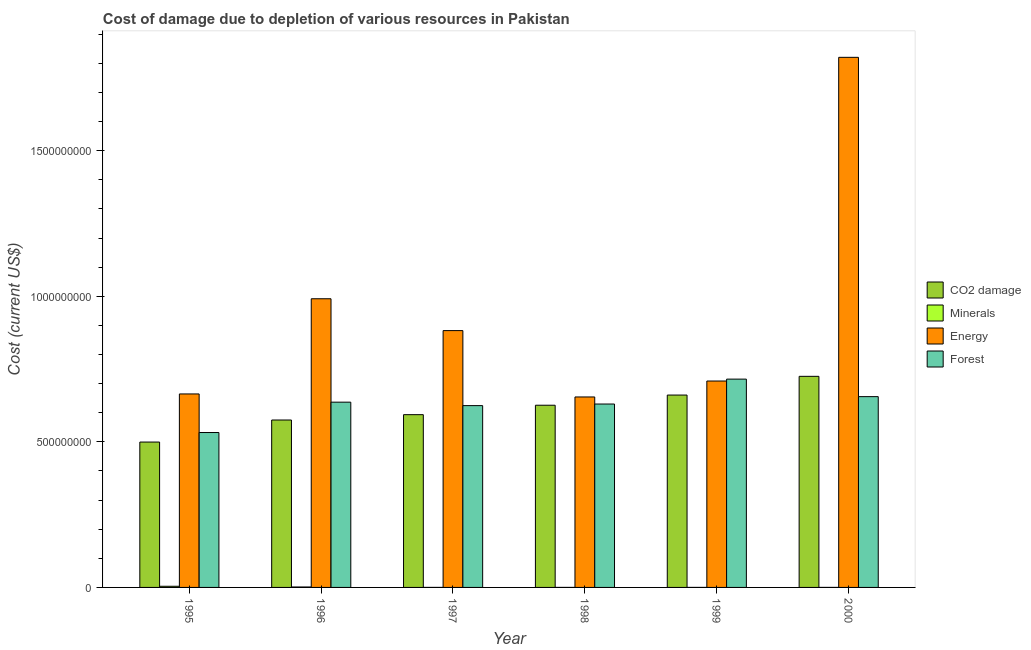Are the number of bars per tick equal to the number of legend labels?
Give a very brief answer. Yes. Are the number of bars on each tick of the X-axis equal?
Your answer should be compact. Yes. How many bars are there on the 1st tick from the left?
Give a very brief answer. 4. How many bars are there on the 1st tick from the right?
Make the answer very short. 4. What is the label of the 2nd group of bars from the left?
Offer a terse response. 1996. In how many cases, is the number of bars for a given year not equal to the number of legend labels?
Provide a short and direct response. 0. What is the cost of damage due to depletion of energy in 2000?
Make the answer very short. 1.82e+09. Across all years, what is the maximum cost of damage due to depletion of coal?
Keep it short and to the point. 7.25e+08. Across all years, what is the minimum cost of damage due to depletion of minerals?
Your answer should be compact. 3.19e+04. In which year was the cost of damage due to depletion of energy maximum?
Offer a very short reply. 2000. In which year was the cost of damage due to depletion of coal minimum?
Your answer should be very brief. 1995. What is the total cost of damage due to depletion of coal in the graph?
Your answer should be very brief. 3.68e+09. What is the difference between the cost of damage due to depletion of minerals in 1999 and that in 2000?
Your answer should be compact. 6647.78. What is the difference between the cost of damage due to depletion of minerals in 1998 and the cost of damage due to depletion of energy in 2000?
Offer a very short reply. -2.28e+04. What is the average cost of damage due to depletion of forests per year?
Offer a very short reply. 6.32e+08. In the year 1996, what is the difference between the cost of damage due to depletion of energy and cost of damage due to depletion of forests?
Offer a very short reply. 0. What is the ratio of the cost of damage due to depletion of energy in 1996 to that in 2000?
Ensure brevity in your answer.  0.54. What is the difference between the highest and the second highest cost of damage due to depletion of coal?
Keep it short and to the point. 6.43e+07. What is the difference between the highest and the lowest cost of damage due to depletion of energy?
Your answer should be very brief. 1.17e+09. Is the sum of the cost of damage due to depletion of forests in 1995 and 1998 greater than the maximum cost of damage due to depletion of coal across all years?
Offer a very short reply. Yes. Is it the case that in every year, the sum of the cost of damage due to depletion of minerals and cost of damage due to depletion of forests is greater than the sum of cost of damage due to depletion of coal and cost of damage due to depletion of energy?
Your response must be concise. No. What does the 1st bar from the left in 1996 represents?
Your answer should be compact. CO2 damage. What does the 2nd bar from the right in 1996 represents?
Your answer should be very brief. Energy. Are all the bars in the graph horizontal?
Your answer should be very brief. No. How many years are there in the graph?
Give a very brief answer. 6. What is the difference between two consecutive major ticks on the Y-axis?
Provide a short and direct response. 5.00e+08. Does the graph contain any zero values?
Offer a very short reply. No. How many legend labels are there?
Keep it short and to the point. 4. What is the title of the graph?
Provide a succinct answer. Cost of damage due to depletion of various resources in Pakistan . What is the label or title of the Y-axis?
Ensure brevity in your answer.  Cost (current US$). What is the Cost (current US$) in CO2 damage in 1995?
Your response must be concise. 4.99e+08. What is the Cost (current US$) of Minerals in 1995?
Make the answer very short. 3.95e+06. What is the Cost (current US$) in Energy in 1995?
Ensure brevity in your answer.  6.64e+08. What is the Cost (current US$) of Forest in 1995?
Your answer should be compact. 5.32e+08. What is the Cost (current US$) in CO2 damage in 1996?
Your response must be concise. 5.75e+08. What is the Cost (current US$) in Minerals in 1996?
Keep it short and to the point. 1.50e+06. What is the Cost (current US$) in Energy in 1996?
Make the answer very short. 9.91e+08. What is the Cost (current US$) of Forest in 1996?
Provide a succinct answer. 6.36e+08. What is the Cost (current US$) of CO2 damage in 1997?
Keep it short and to the point. 5.93e+08. What is the Cost (current US$) of Minerals in 1997?
Make the answer very short. 3.32e+04. What is the Cost (current US$) of Energy in 1997?
Provide a short and direct response. 8.82e+08. What is the Cost (current US$) of Forest in 1997?
Make the answer very short. 6.24e+08. What is the Cost (current US$) of CO2 damage in 1998?
Provide a short and direct response. 6.26e+08. What is the Cost (current US$) of Minerals in 1998?
Make the answer very short. 3.19e+04. What is the Cost (current US$) of Energy in 1998?
Give a very brief answer. 6.54e+08. What is the Cost (current US$) in Forest in 1998?
Your answer should be compact. 6.30e+08. What is the Cost (current US$) in CO2 damage in 1999?
Offer a terse response. 6.61e+08. What is the Cost (current US$) in Minerals in 1999?
Offer a very short reply. 6.14e+04. What is the Cost (current US$) of Energy in 1999?
Your response must be concise. 7.09e+08. What is the Cost (current US$) in Forest in 1999?
Offer a very short reply. 7.15e+08. What is the Cost (current US$) of CO2 damage in 2000?
Your answer should be compact. 7.25e+08. What is the Cost (current US$) of Minerals in 2000?
Offer a terse response. 5.47e+04. What is the Cost (current US$) of Energy in 2000?
Your answer should be compact. 1.82e+09. What is the Cost (current US$) of Forest in 2000?
Offer a very short reply. 6.55e+08. Across all years, what is the maximum Cost (current US$) of CO2 damage?
Keep it short and to the point. 7.25e+08. Across all years, what is the maximum Cost (current US$) of Minerals?
Your answer should be very brief. 3.95e+06. Across all years, what is the maximum Cost (current US$) of Energy?
Your answer should be compact. 1.82e+09. Across all years, what is the maximum Cost (current US$) of Forest?
Provide a succinct answer. 7.15e+08. Across all years, what is the minimum Cost (current US$) of CO2 damage?
Keep it short and to the point. 4.99e+08. Across all years, what is the minimum Cost (current US$) of Minerals?
Provide a succinct answer. 3.19e+04. Across all years, what is the minimum Cost (current US$) in Energy?
Your answer should be compact. 6.54e+08. Across all years, what is the minimum Cost (current US$) of Forest?
Your answer should be very brief. 5.32e+08. What is the total Cost (current US$) of CO2 damage in the graph?
Ensure brevity in your answer.  3.68e+09. What is the total Cost (current US$) of Minerals in the graph?
Provide a succinct answer. 5.63e+06. What is the total Cost (current US$) of Energy in the graph?
Offer a very short reply. 5.72e+09. What is the total Cost (current US$) of Forest in the graph?
Provide a short and direct response. 3.79e+09. What is the difference between the Cost (current US$) of CO2 damage in 1995 and that in 1996?
Offer a very short reply. -7.57e+07. What is the difference between the Cost (current US$) in Minerals in 1995 and that in 1996?
Ensure brevity in your answer.  2.45e+06. What is the difference between the Cost (current US$) of Energy in 1995 and that in 1996?
Your answer should be very brief. -3.27e+08. What is the difference between the Cost (current US$) in Forest in 1995 and that in 1996?
Give a very brief answer. -1.04e+08. What is the difference between the Cost (current US$) in CO2 damage in 1995 and that in 1997?
Ensure brevity in your answer.  -9.41e+07. What is the difference between the Cost (current US$) of Minerals in 1995 and that in 1997?
Make the answer very short. 3.92e+06. What is the difference between the Cost (current US$) of Energy in 1995 and that in 1997?
Your answer should be compact. -2.18e+08. What is the difference between the Cost (current US$) of Forest in 1995 and that in 1997?
Make the answer very short. -9.24e+07. What is the difference between the Cost (current US$) in CO2 damage in 1995 and that in 1998?
Your response must be concise. -1.27e+08. What is the difference between the Cost (current US$) in Minerals in 1995 and that in 1998?
Your answer should be very brief. 3.92e+06. What is the difference between the Cost (current US$) of Energy in 1995 and that in 1998?
Provide a succinct answer. 1.03e+07. What is the difference between the Cost (current US$) of Forest in 1995 and that in 1998?
Your response must be concise. -9.79e+07. What is the difference between the Cost (current US$) in CO2 damage in 1995 and that in 1999?
Your answer should be compact. -1.61e+08. What is the difference between the Cost (current US$) in Minerals in 1995 and that in 1999?
Give a very brief answer. 3.89e+06. What is the difference between the Cost (current US$) in Energy in 1995 and that in 1999?
Your response must be concise. -4.44e+07. What is the difference between the Cost (current US$) of Forest in 1995 and that in 1999?
Ensure brevity in your answer.  -1.83e+08. What is the difference between the Cost (current US$) in CO2 damage in 1995 and that in 2000?
Your answer should be very brief. -2.26e+08. What is the difference between the Cost (current US$) in Minerals in 1995 and that in 2000?
Make the answer very short. 3.90e+06. What is the difference between the Cost (current US$) in Energy in 1995 and that in 2000?
Keep it short and to the point. -1.16e+09. What is the difference between the Cost (current US$) in Forest in 1995 and that in 2000?
Your response must be concise. -1.23e+08. What is the difference between the Cost (current US$) in CO2 damage in 1996 and that in 1997?
Provide a short and direct response. -1.84e+07. What is the difference between the Cost (current US$) of Minerals in 1996 and that in 1997?
Keep it short and to the point. 1.47e+06. What is the difference between the Cost (current US$) of Energy in 1996 and that in 1997?
Your answer should be compact. 1.09e+08. What is the difference between the Cost (current US$) in Forest in 1996 and that in 1997?
Give a very brief answer. 1.18e+07. What is the difference between the Cost (current US$) of CO2 damage in 1996 and that in 1998?
Your response must be concise. -5.08e+07. What is the difference between the Cost (current US$) in Minerals in 1996 and that in 1998?
Offer a terse response. 1.47e+06. What is the difference between the Cost (current US$) of Energy in 1996 and that in 1998?
Offer a terse response. 3.37e+08. What is the difference between the Cost (current US$) of Forest in 1996 and that in 1998?
Provide a succinct answer. 6.40e+06. What is the difference between the Cost (current US$) in CO2 damage in 1996 and that in 1999?
Provide a succinct answer. -8.57e+07. What is the difference between the Cost (current US$) in Minerals in 1996 and that in 1999?
Make the answer very short. 1.44e+06. What is the difference between the Cost (current US$) in Energy in 1996 and that in 1999?
Provide a succinct answer. 2.83e+08. What is the difference between the Cost (current US$) in Forest in 1996 and that in 1999?
Keep it short and to the point. -7.91e+07. What is the difference between the Cost (current US$) in CO2 damage in 1996 and that in 2000?
Your answer should be very brief. -1.50e+08. What is the difference between the Cost (current US$) in Minerals in 1996 and that in 2000?
Your response must be concise. 1.45e+06. What is the difference between the Cost (current US$) of Energy in 1996 and that in 2000?
Your response must be concise. -8.29e+08. What is the difference between the Cost (current US$) in Forest in 1996 and that in 2000?
Make the answer very short. -1.90e+07. What is the difference between the Cost (current US$) of CO2 damage in 1997 and that in 1998?
Provide a short and direct response. -3.24e+07. What is the difference between the Cost (current US$) of Minerals in 1997 and that in 1998?
Provide a succinct answer. 1244.87. What is the difference between the Cost (current US$) of Energy in 1997 and that in 1998?
Make the answer very short. 2.28e+08. What is the difference between the Cost (current US$) of Forest in 1997 and that in 1998?
Keep it short and to the point. -5.44e+06. What is the difference between the Cost (current US$) in CO2 damage in 1997 and that in 1999?
Ensure brevity in your answer.  -6.74e+07. What is the difference between the Cost (current US$) in Minerals in 1997 and that in 1999?
Ensure brevity in your answer.  -2.82e+04. What is the difference between the Cost (current US$) of Energy in 1997 and that in 1999?
Keep it short and to the point. 1.73e+08. What is the difference between the Cost (current US$) of Forest in 1997 and that in 1999?
Provide a short and direct response. -9.10e+07. What is the difference between the Cost (current US$) in CO2 damage in 1997 and that in 2000?
Make the answer very short. -1.32e+08. What is the difference between the Cost (current US$) in Minerals in 1997 and that in 2000?
Your answer should be compact. -2.15e+04. What is the difference between the Cost (current US$) of Energy in 1997 and that in 2000?
Ensure brevity in your answer.  -9.39e+08. What is the difference between the Cost (current US$) of Forest in 1997 and that in 2000?
Keep it short and to the point. -3.09e+07. What is the difference between the Cost (current US$) in CO2 damage in 1998 and that in 1999?
Your answer should be compact. -3.50e+07. What is the difference between the Cost (current US$) of Minerals in 1998 and that in 1999?
Your answer should be compact. -2.94e+04. What is the difference between the Cost (current US$) in Energy in 1998 and that in 1999?
Offer a terse response. -5.47e+07. What is the difference between the Cost (current US$) of Forest in 1998 and that in 1999?
Your answer should be very brief. -8.55e+07. What is the difference between the Cost (current US$) in CO2 damage in 1998 and that in 2000?
Offer a very short reply. -9.92e+07. What is the difference between the Cost (current US$) in Minerals in 1998 and that in 2000?
Your response must be concise. -2.28e+04. What is the difference between the Cost (current US$) of Energy in 1998 and that in 2000?
Keep it short and to the point. -1.17e+09. What is the difference between the Cost (current US$) of Forest in 1998 and that in 2000?
Provide a succinct answer. -2.54e+07. What is the difference between the Cost (current US$) in CO2 damage in 1999 and that in 2000?
Keep it short and to the point. -6.43e+07. What is the difference between the Cost (current US$) in Minerals in 1999 and that in 2000?
Offer a terse response. 6647.78. What is the difference between the Cost (current US$) in Energy in 1999 and that in 2000?
Give a very brief answer. -1.11e+09. What is the difference between the Cost (current US$) of Forest in 1999 and that in 2000?
Make the answer very short. 6.01e+07. What is the difference between the Cost (current US$) in CO2 damage in 1995 and the Cost (current US$) in Minerals in 1996?
Keep it short and to the point. 4.98e+08. What is the difference between the Cost (current US$) of CO2 damage in 1995 and the Cost (current US$) of Energy in 1996?
Make the answer very short. -4.92e+08. What is the difference between the Cost (current US$) in CO2 damage in 1995 and the Cost (current US$) in Forest in 1996?
Provide a short and direct response. -1.37e+08. What is the difference between the Cost (current US$) in Minerals in 1995 and the Cost (current US$) in Energy in 1996?
Ensure brevity in your answer.  -9.87e+08. What is the difference between the Cost (current US$) in Minerals in 1995 and the Cost (current US$) in Forest in 1996?
Offer a very short reply. -6.32e+08. What is the difference between the Cost (current US$) in Energy in 1995 and the Cost (current US$) in Forest in 1996?
Keep it short and to the point. 2.82e+07. What is the difference between the Cost (current US$) in CO2 damage in 1995 and the Cost (current US$) in Minerals in 1997?
Provide a succinct answer. 4.99e+08. What is the difference between the Cost (current US$) of CO2 damage in 1995 and the Cost (current US$) of Energy in 1997?
Offer a very short reply. -3.83e+08. What is the difference between the Cost (current US$) in CO2 damage in 1995 and the Cost (current US$) in Forest in 1997?
Ensure brevity in your answer.  -1.25e+08. What is the difference between the Cost (current US$) in Minerals in 1995 and the Cost (current US$) in Energy in 1997?
Provide a succinct answer. -8.78e+08. What is the difference between the Cost (current US$) in Minerals in 1995 and the Cost (current US$) in Forest in 1997?
Your answer should be compact. -6.20e+08. What is the difference between the Cost (current US$) in Energy in 1995 and the Cost (current US$) in Forest in 1997?
Give a very brief answer. 4.00e+07. What is the difference between the Cost (current US$) in CO2 damage in 1995 and the Cost (current US$) in Minerals in 1998?
Provide a succinct answer. 4.99e+08. What is the difference between the Cost (current US$) in CO2 damage in 1995 and the Cost (current US$) in Energy in 1998?
Your answer should be very brief. -1.55e+08. What is the difference between the Cost (current US$) in CO2 damage in 1995 and the Cost (current US$) in Forest in 1998?
Make the answer very short. -1.31e+08. What is the difference between the Cost (current US$) in Minerals in 1995 and the Cost (current US$) in Energy in 1998?
Provide a succinct answer. -6.50e+08. What is the difference between the Cost (current US$) of Minerals in 1995 and the Cost (current US$) of Forest in 1998?
Offer a terse response. -6.26e+08. What is the difference between the Cost (current US$) of Energy in 1995 and the Cost (current US$) of Forest in 1998?
Make the answer very short. 3.46e+07. What is the difference between the Cost (current US$) of CO2 damage in 1995 and the Cost (current US$) of Minerals in 1999?
Provide a short and direct response. 4.99e+08. What is the difference between the Cost (current US$) in CO2 damage in 1995 and the Cost (current US$) in Energy in 1999?
Give a very brief answer. -2.10e+08. What is the difference between the Cost (current US$) in CO2 damage in 1995 and the Cost (current US$) in Forest in 1999?
Offer a terse response. -2.16e+08. What is the difference between the Cost (current US$) in Minerals in 1995 and the Cost (current US$) in Energy in 1999?
Provide a succinct answer. -7.05e+08. What is the difference between the Cost (current US$) in Minerals in 1995 and the Cost (current US$) in Forest in 1999?
Provide a succinct answer. -7.11e+08. What is the difference between the Cost (current US$) of Energy in 1995 and the Cost (current US$) of Forest in 1999?
Your response must be concise. -5.09e+07. What is the difference between the Cost (current US$) in CO2 damage in 1995 and the Cost (current US$) in Minerals in 2000?
Ensure brevity in your answer.  4.99e+08. What is the difference between the Cost (current US$) of CO2 damage in 1995 and the Cost (current US$) of Energy in 2000?
Offer a terse response. -1.32e+09. What is the difference between the Cost (current US$) in CO2 damage in 1995 and the Cost (current US$) in Forest in 2000?
Offer a terse response. -1.56e+08. What is the difference between the Cost (current US$) of Minerals in 1995 and the Cost (current US$) of Energy in 2000?
Your response must be concise. -1.82e+09. What is the difference between the Cost (current US$) of Minerals in 1995 and the Cost (current US$) of Forest in 2000?
Provide a short and direct response. -6.51e+08. What is the difference between the Cost (current US$) in Energy in 1995 and the Cost (current US$) in Forest in 2000?
Offer a very short reply. 9.19e+06. What is the difference between the Cost (current US$) in CO2 damage in 1996 and the Cost (current US$) in Minerals in 1997?
Your answer should be very brief. 5.75e+08. What is the difference between the Cost (current US$) in CO2 damage in 1996 and the Cost (current US$) in Energy in 1997?
Give a very brief answer. -3.07e+08. What is the difference between the Cost (current US$) of CO2 damage in 1996 and the Cost (current US$) of Forest in 1997?
Provide a short and direct response. -4.94e+07. What is the difference between the Cost (current US$) in Minerals in 1996 and the Cost (current US$) in Energy in 1997?
Ensure brevity in your answer.  -8.81e+08. What is the difference between the Cost (current US$) of Minerals in 1996 and the Cost (current US$) of Forest in 1997?
Offer a very short reply. -6.23e+08. What is the difference between the Cost (current US$) of Energy in 1996 and the Cost (current US$) of Forest in 1997?
Your answer should be compact. 3.67e+08. What is the difference between the Cost (current US$) of CO2 damage in 1996 and the Cost (current US$) of Minerals in 1998?
Ensure brevity in your answer.  5.75e+08. What is the difference between the Cost (current US$) of CO2 damage in 1996 and the Cost (current US$) of Energy in 1998?
Offer a very short reply. -7.91e+07. What is the difference between the Cost (current US$) of CO2 damage in 1996 and the Cost (current US$) of Forest in 1998?
Offer a very short reply. -5.49e+07. What is the difference between the Cost (current US$) in Minerals in 1996 and the Cost (current US$) in Energy in 1998?
Give a very brief answer. -6.53e+08. What is the difference between the Cost (current US$) in Minerals in 1996 and the Cost (current US$) in Forest in 1998?
Keep it short and to the point. -6.28e+08. What is the difference between the Cost (current US$) of Energy in 1996 and the Cost (current US$) of Forest in 1998?
Provide a short and direct response. 3.62e+08. What is the difference between the Cost (current US$) of CO2 damage in 1996 and the Cost (current US$) of Minerals in 1999?
Make the answer very short. 5.75e+08. What is the difference between the Cost (current US$) in CO2 damage in 1996 and the Cost (current US$) in Energy in 1999?
Provide a succinct answer. -1.34e+08. What is the difference between the Cost (current US$) of CO2 damage in 1996 and the Cost (current US$) of Forest in 1999?
Your answer should be compact. -1.40e+08. What is the difference between the Cost (current US$) of Minerals in 1996 and the Cost (current US$) of Energy in 1999?
Give a very brief answer. -7.07e+08. What is the difference between the Cost (current US$) in Minerals in 1996 and the Cost (current US$) in Forest in 1999?
Ensure brevity in your answer.  -7.14e+08. What is the difference between the Cost (current US$) in Energy in 1996 and the Cost (current US$) in Forest in 1999?
Your response must be concise. 2.76e+08. What is the difference between the Cost (current US$) in CO2 damage in 1996 and the Cost (current US$) in Minerals in 2000?
Your answer should be compact. 5.75e+08. What is the difference between the Cost (current US$) of CO2 damage in 1996 and the Cost (current US$) of Energy in 2000?
Your answer should be very brief. -1.25e+09. What is the difference between the Cost (current US$) of CO2 damage in 1996 and the Cost (current US$) of Forest in 2000?
Give a very brief answer. -8.03e+07. What is the difference between the Cost (current US$) of Minerals in 1996 and the Cost (current US$) of Energy in 2000?
Make the answer very short. -1.82e+09. What is the difference between the Cost (current US$) in Minerals in 1996 and the Cost (current US$) in Forest in 2000?
Provide a succinct answer. -6.54e+08. What is the difference between the Cost (current US$) in Energy in 1996 and the Cost (current US$) in Forest in 2000?
Provide a short and direct response. 3.36e+08. What is the difference between the Cost (current US$) in CO2 damage in 1997 and the Cost (current US$) in Minerals in 1998?
Your response must be concise. 5.93e+08. What is the difference between the Cost (current US$) in CO2 damage in 1997 and the Cost (current US$) in Energy in 1998?
Your response must be concise. -6.08e+07. What is the difference between the Cost (current US$) of CO2 damage in 1997 and the Cost (current US$) of Forest in 1998?
Keep it short and to the point. -3.65e+07. What is the difference between the Cost (current US$) of Minerals in 1997 and the Cost (current US$) of Energy in 1998?
Your response must be concise. -6.54e+08. What is the difference between the Cost (current US$) of Minerals in 1997 and the Cost (current US$) of Forest in 1998?
Provide a succinct answer. -6.30e+08. What is the difference between the Cost (current US$) of Energy in 1997 and the Cost (current US$) of Forest in 1998?
Offer a terse response. 2.52e+08. What is the difference between the Cost (current US$) of CO2 damage in 1997 and the Cost (current US$) of Minerals in 1999?
Provide a short and direct response. 5.93e+08. What is the difference between the Cost (current US$) in CO2 damage in 1997 and the Cost (current US$) in Energy in 1999?
Keep it short and to the point. -1.16e+08. What is the difference between the Cost (current US$) in CO2 damage in 1997 and the Cost (current US$) in Forest in 1999?
Your answer should be very brief. -1.22e+08. What is the difference between the Cost (current US$) of Minerals in 1997 and the Cost (current US$) of Energy in 1999?
Offer a very short reply. -7.09e+08. What is the difference between the Cost (current US$) of Minerals in 1997 and the Cost (current US$) of Forest in 1999?
Make the answer very short. -7.15e+08. What is the difference between the Cost (current US$) of Energy in 1997 and the Cost (current US$) of Forest in 1999?
Give a very brief answer. 1.67e+08. What is the difference between the Cost (current US$) in CO2 damage in 1997 and the Cost (current US$) in Minerals in 2000?
Give a very brief answer. 5.93e+08. What is the difference between the Cost (current US$) of CO2 damage in 1997 and the Cost (current US$) of Energy in 2000?
Provide a succinct answer. -1.23e+09. What is the difference between the Cost (current US$) of CO2 damage in 1997 and the Cost (current US$) of Forest in 2000?
Ensure brevity in your answer.  -6.19e+07. What is the difference between the Cost (current US$) of Minerals in 1997 and the Cost (current US$) of Energy in 2000?
Keep it short and to the point. -1.82e+09. What is the difference between the Cost (current US$) in Minerals in 1997 and the Cost (current US$) in Forest in 2000?
Give a very brief answer. -6.55e+08. What is the difference between the Cost (current US$) in Energy in 1997 and the Cost (current US$) in Forest in 2000?
Offer a very short reply. 2.27e+08. What is the difference between the Cost (current US$) in CO2 damage in 1998 and the Cost (current US$) in Minerals in 1999?
Make the answer very short. 6.26e+08. What is the difference between the Cost (current US$) of CO2 damage in 1998 and the Cost (current US$) of Energy in 1999?
Your answer should be very brief. -8.31e+07. What is the difference between the Cost (current US$) in CO2 damage in 1998 and the Cost (current US$) in Forest in 1999?
Offer a very short reply. -8.96e+07. What is the difference between the Cost (current US$) of Minerals in 1998 and the Cost (current US$) of Energy in 1999?
Provide a succinct answer. -7.09e+08. What is the difference between the Cost (current US$) in Minerals in 1998 and the Cost (current US$) in Forest in 1999?
Your answer should be very brief. -7.15e+08. What is the difference between the Cost (current US$) in Energy in 1998 and the Cost (current US$) in Forest in 1999?
Provide a succinct answer. -6.13e+07. What is the difference between the Cost (current US$) in CO2 damage in 1998 and the Cost (current US$) in Minerals in 2000?
Your answer should be very brief. 6.26e+08. What is the difference between the Cost (current US$) in CO2 damage in 1998 and the Cost (current US$) in Energy in 2000?
Offer a very short reply. -1.19e+09. What is the difference between the Cost (current US$) of CO2 damage in 1998 and the Cost (current US$) of Forest in 2000?
Ensure brevity in your answer.  -2.95e+07. What is the difference between the Cost (current US$) of Minerals in 1998 and the Cost (current US$) of Energy in 2000?
Keep it short and to the point. -1.82e+09. What is the difference between the Cost (current US$) in Minerals in 1998 and the Cost (current US$) in Forest in 2000?
Provide a short and direct response. -6.55e+08. What is the difference between the Cost (current US$) in Energy in 1998 and the Cost (current US$) in Forest in 2000?
Make the answer very short. -1.16e+06. What is the difference between the Cost (current US$) in CO2 damage in 1999 and the Cost (current US$) in Minerals in 2000?
Keep it short and to the point. 6.61e+08. What is the difference between the Cost (current US$) of CO2 damage in 1999 and the Cost (current US$) of Energy in 2000?
Ensure brevity in your answer.  -1.16e+09. What is the difference between the Cost (current US$) of CO2 damage in 1999 and the Cost (current US$) of Forest in 2000?
Keep it short and to the point. 5.42e+06. What is the difference between the Cost (current US$) of Minerals in 1999 and the Cost (current US$) of Energy in 2000?
Keep it short and to the point. -1.82e+09. What is the difference between the Cost (current US$) in Minerals in 1999 and the Cost (current US$) in Forest in 2000?
Provide a short and direct response. -6.55e+08. What is the difference between the Cost (current US$) of Energy in 1999 and the Cost (current US$) of Forest in 2000?
Keep it short and to the point. 5.36e+07. What is the average Cost (current US$) in CO2 damage per year?
Make the answer very short. 6.13e+08. What is the average Cost (current US$) in Minerals per year?
Offer a very short reply. 9.39e+05. What is the average Cost (current US$) in Energy per year?
Offer a very short reply. 9.54e+08. What is the average Cost (current US$) of Forest per year?
Your answer should be very brief. 6.32e+08. In the year 1995, what is the difference between the Cost (current US$) of CO2 damage and Cost (current US$) of Minerals?
Your response must be concise. 4.95e+08. In the year 1995, what is the difference between the Cost (current US$) of CO2 damage and Cost (current US$) of Energy?
Provide a succinct answer. -1.65e+08. In the year 1995, what is the difference between the Cost (current US$) of CO2 damage and Cost (current US$) of Forest?
Provide a short and direct response. -3.27e+07. In the year 1995, what is the difference between the Cost (current US$) in Minerals and Cost (current US$) in Energy?
Provide a succinct answer. -6.61e+08. In the year 1995, what is the difference between the Cost (current US$) in Minerals and Cost (current US$) in Forest?
Make the answer very short. -5.28e+08. In the year 1995, what is the difference between the Cost (current US$) in Energy and Cost (current US$) in Forest?
Your answer should be very brief. 1.32e+08. In the year 1996, what is the difference between the Cost (current US$) in CO2 damage and Cost (current US$) in Minerals?
Your answer should be very brief. 5.73e+08. In the year 1996, what is the difference between the Cost (current US$) of CO2 damage and Cost (current US$) of Energy?
Your answer should be very brief. -4.16e+08. In the year 1996, what is the difference between the Cost (current US$) in CO2 damage and Cost (current US$) in Forest?
Offer a very short reply. -6.13e+07. In the year 1996, what is the difference between the Cost (current US$) in Minerals and Cost (current US$) in Energy?
Your answer should be compact. -9.90e+08. In the year 1996, what is the difference between the Cost (current US$) in Minerals and Cost (current US$) in Forest?
Ensure brevity in your answer.  -6.35e+08. In the year 1996, what is the difference between the Cost (current US$) of Energy and Cost (current US$) of Forest?
Give a very brief answer. 3.55e+08. In the year 1997, what is the difference between the Cost (current US$) in CO2 damage and Cost (current US$) in Minerals?
Provide a succinct answer. 5.93e+08. In the year 1997, what is the difference between the Cost (current US$) of CO2 damage and Cost (current US$) of Energy?
Ensure brevity in your answer.  -2.89e+08. In the year 1997, what is the difference between the Cost (current US$) of CO2 damage and Cost (current US$) of Forest?
Give a very brief answer. -3.11e+07. In the year 1997, what is the difference between the Cost (current US$) of Minerals and Cost (current US$) of Energy?
Provide a short and direct response. -8.82e+08. In the year 1997, what is the difference between the Cost (current US$) in Minerals and Cost (current US$) in Forest?
Provide a succinct answer. -6.24e+08. In the year 1997, what is the difference between the Cost (current US$) in Energy and Cost (current US$) in Forest?
Your response must be concise. 2.58e+08. In the year 1998, what is the difference between the Cost (current US$) of CO2 damage and Cost (current US$) of Minerals?
Your response must be concise. 6.26e+08. In the year 1998, what is the difference between the Cost (current US$) of CO2 damage and Cost (current US$) of Energy?
Provide a succinct answer. -2.84e+07. In the year 1998, what is the difference between the Cost (current US$) of CO2 damage and Cost (current US$) of Forest?
Provide a short and direct response. -4.11e+06. In the year 1998, what is the difference between the Cost (current US$) in Minerals and Cost (current US$) in Energy?
Give a very brief answer. -6.54e+08. In the year 1998, what is the difference between the Cost (current US$) in Minerals and Cost (current US$) in Forest?
Give a very brief answer. -6.30e+08. In the year 1998, what is the difference between the Cost (current US$) in Energy and Cost (current US$) in Forest?
Keep it short and to the point. 2.43e+07. In the year 1999, what is the difference between the Cost (current US$) of CO2 damage and Cost (current US$) of Minerals?
Provide a short and direct response. 6.61e+08. In the year 1999, what is the difference between the Cost (current US$) of CO2 damage and Cost (current US$) of Energy?
Ensure brevity in your answer.  -4.82e+07. In the year 1999, what is the difference between the Cost (current US$) in CO2 damage and Cost (current US$) in Forest?
Your answer should be compact. -5.47e+07. In the year 1999, what is the difference between the Cost (current US$) of Minerals and Cost (current US$) of Energy?
Offer a terse response. -7.09e+08. In the year 1999, what is the difference between the Cost (current US$) of Minerals and Cost (current US$) of Forest?
Make the answer very short. -7.15e+08. In the year 1999, what is the difference between the Cost (current US$) of Energy and Cost (current US$) of Forest?
Ensure brevity in your answer.  -6.52e+06. In the year 2000, what is the difference between the Cost (current US$) of CO2 damage and Cost (current US$) of Minerals?
Give a very brief answer. 7.25e+08. In the year 2000, what is the difference between the Cost (current US$) of CO2 damage and Cost (current US$) of Energy?
Offer a very short reply. -1.10e+09. In the year 2000, what is the difference between the Cost (current US$) in CO2 damage and Cost (current US$) in Forest?
Provide a short and direct response. 6.97e+07. In the year 2000, what is the difference between the Cost (current US$) of Minerals and Cost (current US$) of Energy?
Offer a terse response. -1.82e+09. In the year 2000, what is the difference between the Cost (current US$) in Minerals and Cost (current US$) in Forest?
Offer a very short reply. -6.55e+08. In the year 2000, what is the difference between the Cost (current US$) of Energy and Cost (current US$) of Forest?
Provide a succinct answer. 1.17e+09. What is the ratio of the Cost (current US$) in CO2 damage in 1995 to that in 1996?
Offer a very short reply. 0.87. What is the ratio of the Cost (current US$) of Minerals in 1995 to that in 1996?
Your answer should be compact. 2.63. What is the ratio of the Cost (current US$) of Energy in 1995 to that in 1996?
Your answer should be very brief. 0.67. What is the ratio of the Cost (current US$) in Forest in 1995 to that in 1996?
Make the answer very short. 0.84. What is the ratio of the Cost (current US$) in CO2 damage in 1995 to that in 1997?
Ensure brevity in your answer.  0.84. What is the ratio of the Cost (current US$) in Minerals in 1995 to that in 1997?
Ensure brevity in your answer.  119.04. What is the ratio of the Cost (current US$) of Energy in 1995 to that in 1997?
Offer a terse response. 0.75. What is the ratio of the Cost (current US$) in Forest in 1995 to that in 1997?
Your response must be concise. 0.85. What is the ratio of the Cost (current US$) in CO2 damage in 1995 to that in 1998?
Offer a terse response. 0.8. What is the ratio of the Cost (current US$) of Minerals in 1995 to that in 1998?
Provide a succinct answer. 123.68. What is the ratio of the Cost (current US$) in Energy in 1995 to that in 1998?
Provide a succinct answer. 1.02. What is the ratio of the Cost (current US$) of Forest in 1995 to that in 1998?
Keep it short and to the point. 0.84. What is the ratio of the Cost (current US$) of CO2 damage in 1995 to that in 1999?
Offer a terse response. 0.76. What is the ratio of the Cost (current US$) of Minerals in 1995 to that in 1999?
Your answer should be compact. 64.38. What is the ratio of the Cost (current US$) of Energy in 1995 to that in 1999?
Your response must be concise. 0.94. What is the ratio of the Cost (current US$) of Forest in 1995 to that in 1999?
Your answer should be very brief. 0.74. What is the ratio of the Cost (current US$) of CO2 damage in 1995 to that in 2000?
Provide a short and direct response. 0.69. What is the ratio of the Cost (current US$) in Minerals in 1995 to that in 2000?
Keep it short and to the point. 72.2. What is the ratio of the Cost (current US$) in Energy in 1995 to that in 2000?
Make the answer very short. 0.36. What is the ratio of the Cost (current US$) of Forest in 1995 to that in 2000?
Keep it short and to the point. 0.81. What is the ratio of the Cost (current US$) in Minerals in 1996 to that in 1997?
Give a very brief answer. 45.26. What is the ratio of the Cost (current US$) in Energy in 1996 to that in 1997?
Your response must be concise. 1.12. What is the ratio of the Cost (current US$) in CO2 damage in 1996 to that in 1998?
Offer a terse response. 0.92. What is the ratio of the Cost (current US$) of Minerals in 1996 to that in 1998?
Provide a short and direct response. 47.02. What is the ratio of the Cost (current US$) in Energy in 1996 to that in 1998?
Give a very brief answer. 1.52. What is the ratio of the Cost (current US$) of Forest in 1996 to that in 1998?
Provide a succinct answer. 1.01. What is the ratio of the Cost (current US$) of CO2 damage in 1996 to that in 1999?
Offer a very short reply. 0.87. What is the ratio of the Cost (current US$) of Minerals in 1996 to that in 1999?
Make the answer very short. 24.48. What is the ratio of the Cost (current US$) in Energy in 1996 to that in 1999?
Offer a terse response. 1.4. What is the ratio of the Cost (current US$) in Forest in 1996 to that in 1999?
Your response must be concise. 0.89. What is the ratio of the Cost (current US$) of CO2 damage in 1996 to that in 2000?
Your response must be concise. 0.79. What is the ratio of the Cost (current US$) of Minerals in 1996 to that in 2000?
Offer a terse response. 27.45. What is the ratio of the Cost (current US$) of Energy in 1996 to that in 2000?
Keep it short and to the point. 0.54. What is the ratio of the Cost (current US$) in Forest in 1996 to that in 2000?
Keep it short and to the point. 0.97. What is the ratio of the Cost (current US$) of CO2 damage in 1997 to that in 1998?
Provide a succinct answer. 0.95. What is the ratio of the Cost (current US$) of Minerals in 1997 to that in 1998?
Ensure brevity in your answer.  1.04. What is the ratio of the Cost (current US$) of Energy in 1997 to that in 1998?
Ensure brevity in your answer.  1.35. What is the ratio of the Cost (current US$) in CO2 damage in 1997 to that in 1999?
Offer a very short reply. 0.9. What is the ratio of the Cost (current US$) in Minerals in 1997 to that in 1999?
Keep it short and to the point. 0.54. What is the ratio of the Cost (current US$) of Energy in 1997 to that in 1999?
Your response must be concise. 1.24. What is the ratio of the Cost (current US$) of Forest in 1997 to that in 1999?
Give a very brief answer. 0.87. What is the ratio of the Cost (current US$) of CO2 damage in 1997 to that in 2000?
Your answer should be very brief. 0.82. What is the ratio of the Cost (current US$) in Minerals in 1997 to that in 2000?
Give a very brief answer. 0.61. What is the ratio of the Cost (current US$) in Energy in 1997 to that in 2000?
Offer a terse response. 0.48. What is the ratio of the Cost (current US$) of Forest in 1997 to that in 2000?
Offer a very short reply. 0.95. What is the ratio of the Cost (current US$) in CO2 damage in 1998 to that in 1999?
Ensure brevity in your answer.  0.95. What is the ratio of the Cost (current US$) in Minerals in 1998 to that in 1999?
Offer a very short reply. 0.52. What is the ratio of the Cost (current US$) of Energy in 1998 to that in 1999?
Keep it short and to the point. 0.92. What is the ratio of the Cost (current US$) of Forest in 1998 to that in 1999?
Keep it short and to the point. 0.88. What is the ratio of the Cost (current US$) in CO2 damage in 1998 to that in 2000?
Provide a succinct answer. 0.86. What is the ratio of the Cost (current US$) of Minerals in 1998 to that in 2000?
Your answer should be very brief. 0.58. What is the ratio of the Cost (current US$) of Energy in 1998 to that in 2000?
Keep it short and to the point. 0.36. What is the ratio of the Cost (current US$) in Forest in 1998 to that in 2000?
Your answer should be very brief. 0.96. What is the ratio of the Cost (current US$) in CO2 damage in 1999 to that in 2000?
Your response must be concise. 0.91. What is the ratio of the Cost (current US$) in Minerals in 1999 to that in 2000?
Your response must be concise. 1.12. What is the ratio of the Cost (current US$) in Energy in 1999 to that in 2000?
Offer a terse response. 0.39. What is the ratio of the Cost (current US$) of Forest in 1999 to that in 2000?
Offer a terse response. 1.09. What is the difference between the highest and the second highest Cost (current US$) in CO2 damage?
Provide a short and direct response. 6.43e+07. What is the difference between the highest and the second highest Cost (current US$) of Minerals?
Ensure brevity in your answer.  2.45e+06. What is the difference between the highest and the second highest Cost (current US$) of Energy?
Ensure brevity in your answer.  8.29e+08. What is the difference between the highest and the second highest Cost (current US$) of Forest?
Offer a very short reply. 6.01e+07. What is the difference between the highest and the lowest Cost (current US$) in CO2 damage?
Ensure brevity in your answer.  2.26e+08. What is the difference between the highest and the lowest Cost (current US$) in Minerals?
Make the answer very short. 3.92e+06. What is the difference between the highest and the lowest Cost (current US$) in Energy?
Your response must be concise. 1.17e+09. What is the difference between the highest and the lowest Cost (current US$) in Forest?
Provide a succinct answer. 1.83e+08. 